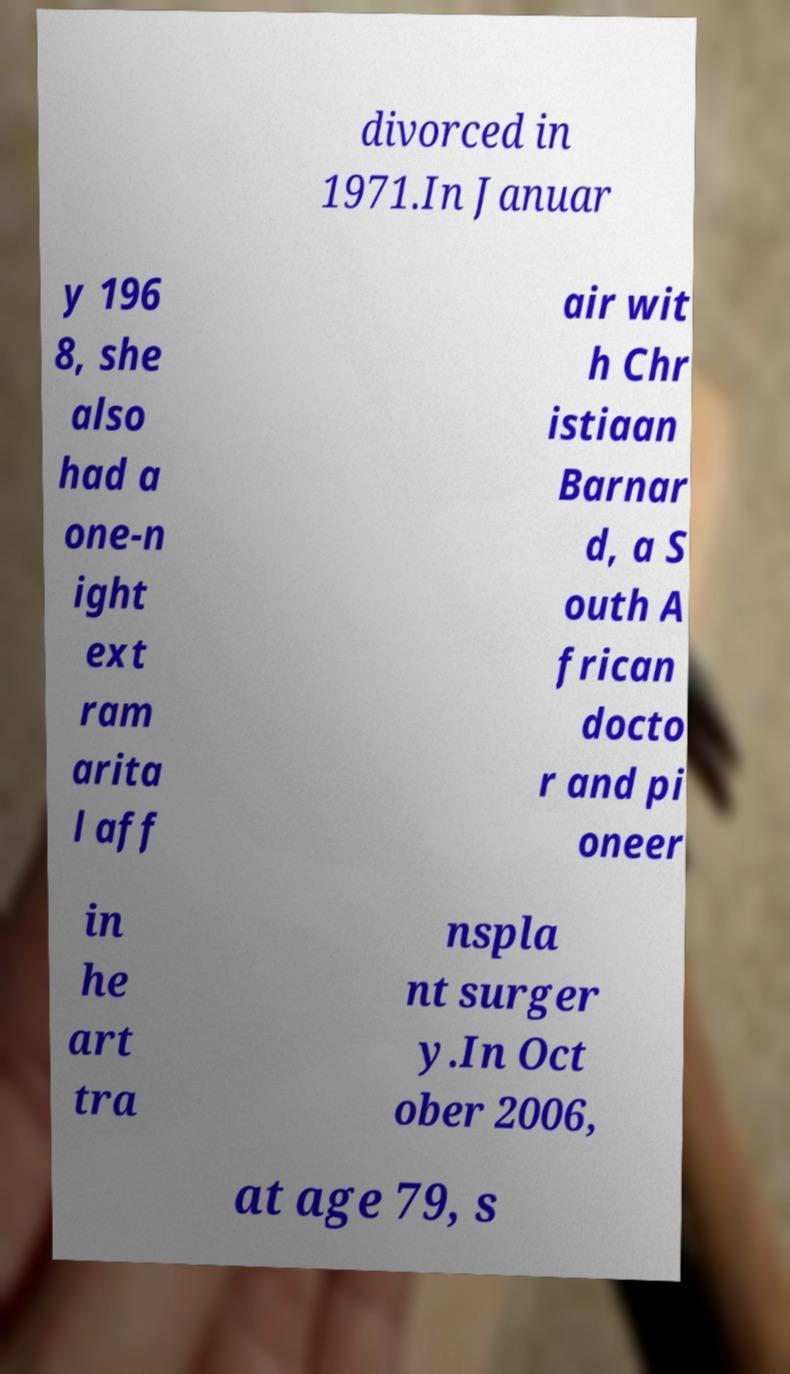What messages or text are displayed in this image? I need them in a readable, typed format. divorced in 1971.In Januar y 196 8, she also had a one-n ight ext ram arita l aff air wit h Chr istiaan Barnar d, a S outh A frican docto r and pi oneer in he art tra nspla nt surger y.In Oct ober 2006, at age 79, s 